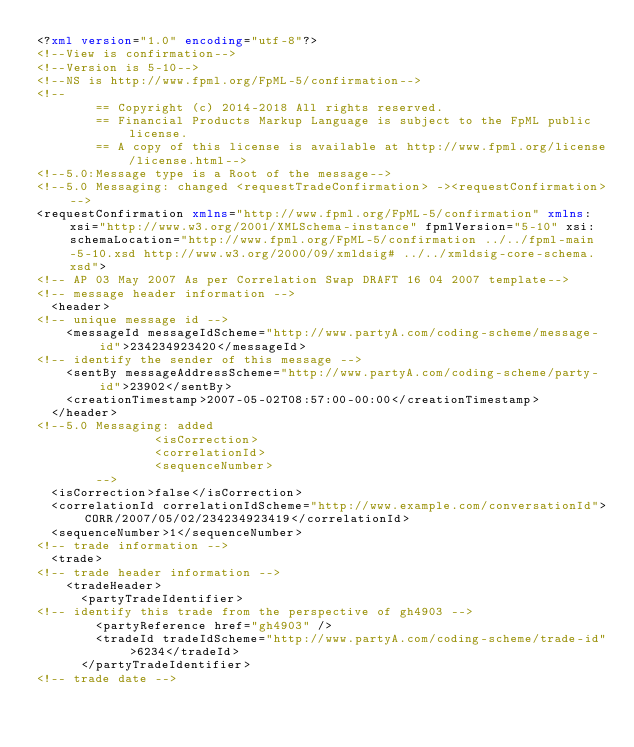<code> <loc_0><loc_0><loc_500><loc_500><_XML_><?xml version="1.0" encoding="utf-8"?>
<!--View is confirmation-->
<!--Version is 5-10-->
<!--NS is http://www.fpml.org/FpML-5/confirmation-->
<!-- 
        == Copyright (c) 2014-2018 All rights reserved. 
        == Financial Products Markup Language is subject to the FpML public license. 
        == A copy of this license is available at http://www.fpml.org/license/license.html-->
<!--5.0:Message type is a Root of the message-->
<!--5.0 Messaging: changed <requestTradeConfirmation> -><requestConfirmation>-->
<requestConfirmation xmlns="http://www.fpml.org/FpML-5/confirmation" xmlns:xsi="http://www.w3.org/2001/XMLSchema-instance" fpmlVersion="5-10" xsi:schemaLocation="http://www.fpml.org/FpML-5/confirmation ../../fpml-main-5-10.xsd http://www.w3.org/2000/09/xmldsig# ../../xmldsig-core-schema.xsd">
<!-- AP 03 May 2007 As per Correlation Swap DRAFT 16 04 2007 template-->
<!-- message header information -->
  <header>
<!-- unique message id -->
    <messageId messageIdScheme="http://www.partyA.com/coding-scheme/message-id">234234923420</messageId>
<!-- identify the sender of this message -->
    <sentBy messageAddressScheme="http://www.partyA.com/coding-scheme/party-id">23902</sentBy>
    <creationTimestamp>2007-05-02T08:57:00-00:00</creationTimestamp>
  </header>
<!--5.0 Messaging: added
                <isCorrection>
                <correlationId>
                <sequenceNumber>
        -->
  <isCorrection>false</isCorrection>
  <correlationId correlationIdScheme="http://www.example.com/conversationId">CORR/2007/05/02/234234923419</correlationId>
  <sequenceNumber>1</sequenceNumber>
<!-- trade information -->
  <trade>
<!-- trade header information -->
    <tradeHeader>
      <partyTradeIdentifier>
<!-- identify this trade from the perspective of gh4903 -->
        <partyReference href="gh4903" />
        <tradeId tradeIdScheme="http://www.partyA.com/coding-scheme/trade-id">6234</tradeId>
      </partyTradeIdentifier>
<!-- trade date --></code> 